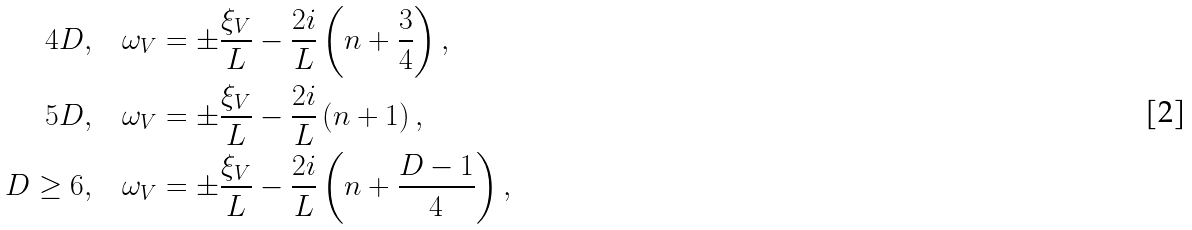<formula> <loc_0><loc_0><loc_500><loc_500>4 D , & \quad \omega _ { V } = \pm \frac { \xi _ { V } } { L } - \frac { 2 i } { L } \left ( n + \frac { 3 } { 4 } \right ) , \\ 5 D , & \quad \omega _ { V } = \pm \frac { \xi _ { V } } { L } - \frac { 2 i } { L } \left ( n + 1 \right ) , \\ D \geq 6 , & \quad \omega _ { V } = \pm \frac { \xi _ { V } } { L } - \frac { 2 i } { L } \left ( n + \frac { D - 1 } { 4 } \right ) ,</formula> 